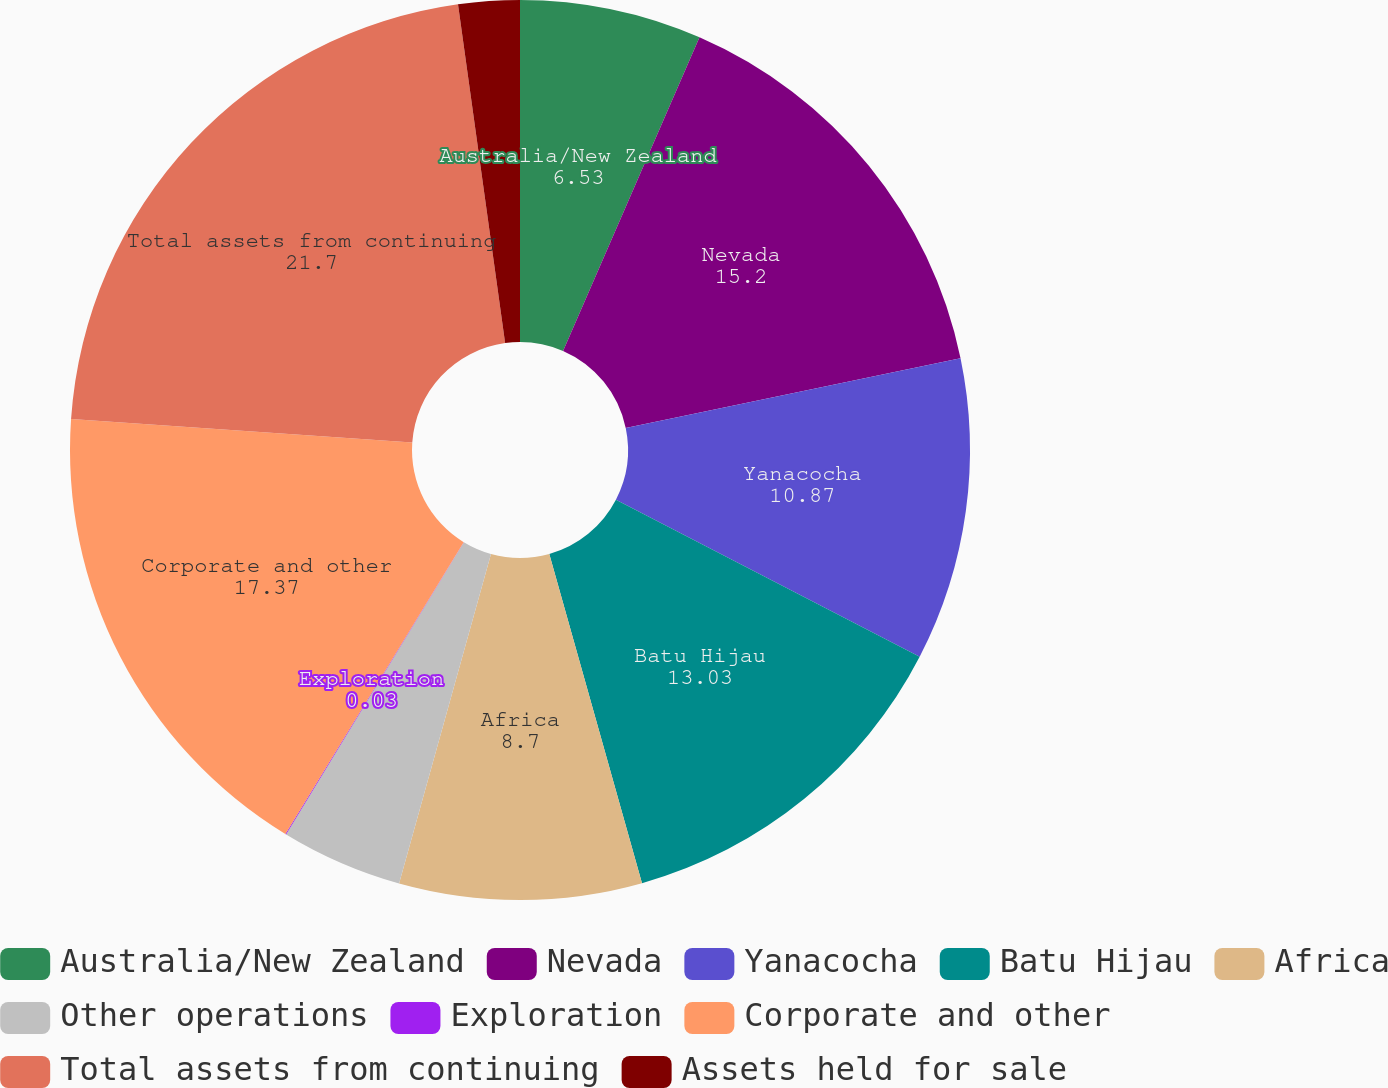<chart> <loc_0><loc_0><loc_500><loc_500><pie_chart><fcel>Australia/New Zealand<fcel>Nevada<fcel>Yanacocha<fcel>Batu Hijau<fcel>Africa<fcel>Other operations<fcel>Exploration<fcel>Corporate and other<fcel>Total assets from continuing<fcel>Assets held for sale<nl><fcel>6.53%<fcel>15.2%<fcel>10.87%<fcel>13.03%<fcel>8.7%<fcel>4.37%<fcel>0.03%<fcel>17.37%<fcel>21.7%<fcel>2.2%<nl></chart> 